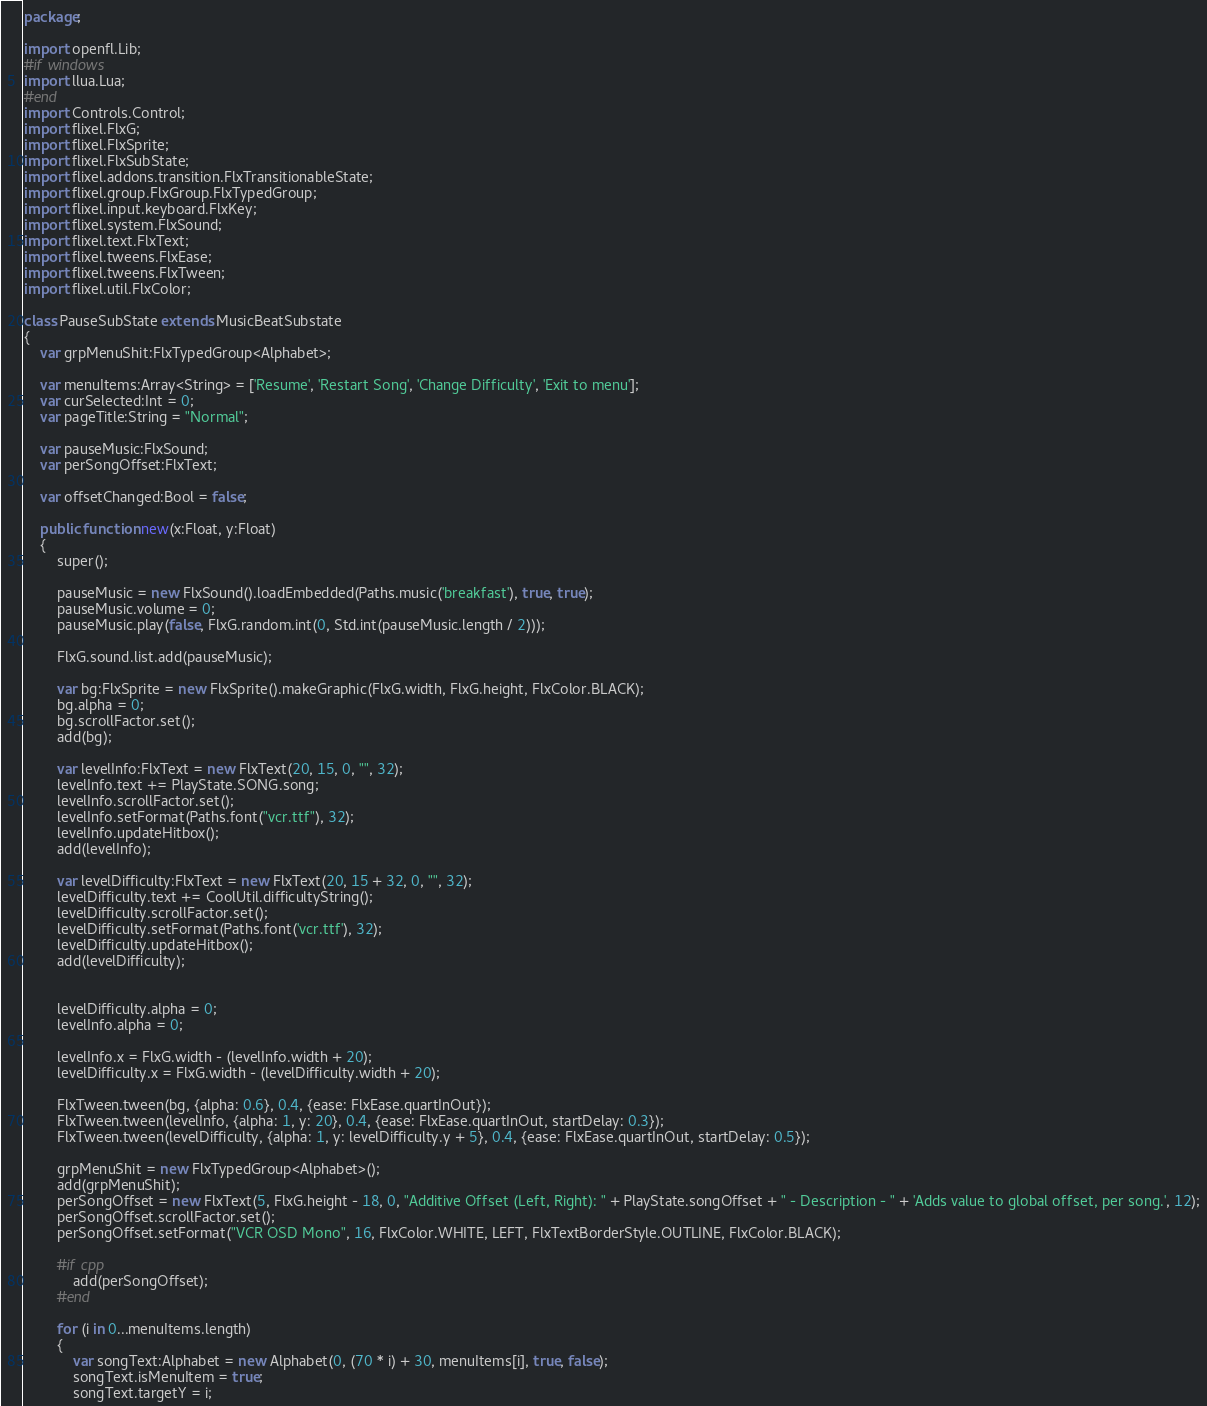Convert code to text. <code><loc_0><loc_0><loc_500><loc_500><_Haxe_>package;

import openfl.Lib;
#if windows
import llua.Lua;
#end
import Controls.Control;
import flixel.FlxG;
import flixel.FlxSprite;
import flixel.FlxSubState;
import flixel.addons.transition.FlxTransitionableState;
import flixel.group.FlxGroup.FlxTypedGroup;
import flixel.input.keyboard.FlxKey;
import flixel.system.FlxSound;
import flixel.text.FlxText;
import flixel.tweens.FlxEase;
import flixel.tweens.FlxTween;
import flixel.util.FlxColor;

class PauseSubState extends MusicBeatSubstate
{
	var grpMenuShit:FlxTypedGroup<Alphabet>;

	var menuItems:Array<String> = ['Resume', 'Restart Song', 'Change Difficulty', 'Exit to menu'];
	var curSelected:Int = 0;
	var pageTitle:String = "Normal";

	var pauseMusic:FlxSound;
	var perSongOffset:FlxText;
	
	var offsetChanged:Bool = false;

	public function new(x:Float, y:Float)
	{
		super();

		pauseMusic = new FlxSound().loadEmbedded(Paths.music('breakfast'), true, true);
		pauseMusic.volume = 0;
		pauseMusic.play(false, FlxG.random.int(0, Std.int(pauseMusic.length / 2)));

		FlxG.sound.list.add(pauseMusic);

		var bg:FlxSprite = new FlxSprite().makeGraphic(FlxG.width, FlxG.height, FlxColor.BLACK);
		bg.alpha = 0;
		bg.scrollFactor.set();
		add(bg);

		var levelInfo:FlxText = new FlxText(20, 15, 0, "", 32);
		levelInfo.text += PlayState.SONG.song;
		levelInfo.scrollFactor.set();
		levelInfo.setFormat(Paths.font("vcr.ttf"), 32);
		levelInfo.updateHitbox();
		add(levelInfo);

		var levelDifficulty:FlxText = new FlxText(20, 15 + 32, 0, "", 32);
		levelDifficulty.text += CoolUtil.difficultyString();
		levelDifficulty.scrollFactor.set();
		levelDifficulty.setFormat(Paths.font('vcr.ttf'), 32);
		levelDifficulty.updateHitbox();
		add(levelDifficulty);


		levelDifficulty.alpha = 0;
		levelInfo.alpha = 0;

		levelInfo.x = FlxG.width - (levelInfo.width + 20);
		levelDifficulty.x = FlxG.width - (levelDifficulty.width + 20);

		FlxTween.tween(bg, {alpha: 0.6}, 0.4, {ease: FlxEase.quartInOut});
		FlxTween.tween(levelInfo, {alpha: 1, y: 20}, 0.4, {ease: FlxEase.quartInOut, startDelay: 0.3});
		FlxTween.tween(levelDifficulty, {alpha: 1, y: levelDifficulty.y + 5}, 0.4, {ease: FlxEase.quartInOut, startDelay: 0.5});

		grpMenuShit = new FlxTypedGroup<Alphabet>();
		add(grpMenuShit);
		perSongOffset = new FlxText(5, FlxG.height - 18, 0, "Additive Offset (Left, Right): " + PlayState.songOffset + " - Description - " + 'Adds value to global offset, per song.', 12);
		perSongOffset.scrollFactor.set();
		perSongOffset.setFormat("VCR OSD Mono", 16, FlxColor.WHITE, LEFT, FlxTextBorderStyle.OUTLINE, FlxColor.BLACK);
		
		#if cpp
			add(perSongOffset);
		#end

		for (i in 0...menuItems.length)
		{
			var songText:Alphabet = new Alphabet(0, (70 * i) + 30, menuItems[i], true, false);
			songText.isMenuItem = true;
			songText.targetY = i;</code> 